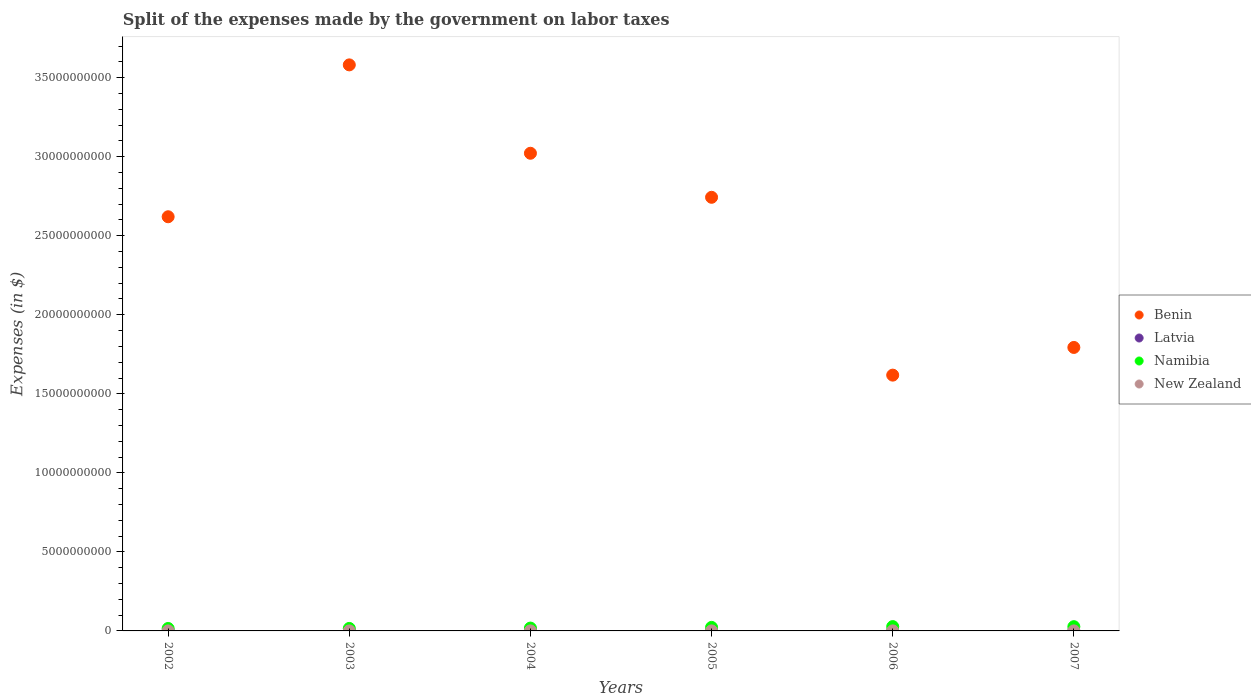How many different coloured dotlines are there?
Offer a terse response. 4. Is the number of dotlines equal to the number of legend labels?
Make the answer very short. Yes. What is the expenses made by the government on labor taxes in Latvia in 2002?
Your answer should be compact. 8.60e+06. Across all years, what is the maximum expenses made by the government on labor taxes in Namibia?
Your answer should be compact. 2.73e+08. Across all years, what is the minimum expenses made by the government on labor taxes in Benin?
Offer a terse response. 1.62e+1. In which year was the expenses made by the government on labor taxes in Namibia minimum?
Provide a succinct answer. 2002. What is the total expenses made by the government on labor taxes in Benin in the graph?
Your response must be concise. 1.54e+11. What is the difference between the expenses made by the government on labor taxes in New Zealand in 2005 and that in 2007?
Ensure brevity in your answer.  3.25e+05. What is the difference between the expenses made by the government on labor taxes in Namibia in 2002 and the expenses made by the government on labor taxes in New Zealand in 2003?
Give a very brief answer. 1.53e+08. What is the average expenses made by the government on labor taxes in Latvia per year?
Give a very brief answer. 7.77e+06. In the year 2002, what is the difference between the expenses made by the government on labor taxes in Latvia and expenses made by the government on labor taxes in Namibia?
Give a very brief answer. -1.46e+08. What is the ratio of the expenses made by the government on labor taxes in New Zealand in 2002 to that in 2007?
Provide a short and direct response. 0.66. Is the expenses made by the government on labor taxes in Latvia in 2002 less than that in 2005?
Provide a succinct answer. No. What is the difference between the highest and the second highest expenses made by the government on labor taxes in Latvia?
Make the answer very short. 2.00e+05. What is the difference between the highest and the lowest expenses made by the government on labor taxes in New Zealand?
Your answer should be very brief. 1.69e+06. Is the sum of the expenses made by the government on labor taxes in Latvia in 2002 and 2007 greater than the maximum expenses made by the government on labor taxes in Benin across all years?
Make the answer very short. No. Is it the case that in every year, the sum of the expenses made by the government on labor taxes in Namibia and expenses made by the government on labor taxes in Latvia  is greater than the sum of expenses made by the government on labor taxes in Benin and expenses made by the government on labor taxes in New Zealand?
Provide a short and direct response. No. Is the expenses made by the government on labor taxes in Latvia strictly less than the expenses made by the government on labor taxes in Namibia over the years?
Provide a succinct answer. Yes. How many years are there in the graph?
Give a very brief answer. 6. What is the difference between two consecutive major ticks on the Y-axis?
Provide a short and direct response. 5.00e+09. Are the values on the major ticks of Y-axis written in scientific E-notation?
Offer a very short reply. No. Does the graph contain any zero values?
Offer a terse response. No. Does the graph contain grids?
Your answer should be very brief. No. How are the legend labels stacked?
Provide a succinct answer. Vertical. What is the title of the graph?
Your answer should be compact. Split of the expenses made by the government on labor taxes. What is the label or title of the X-axis?
Offer a very short reply. Years. What is the label or title of the Y-axis?
Your answer should be compact. Expenses (in $). What is the Expenses (in $) in Benin in 2002?
Provide a succinct answer. 2.62e+1. What is the Expenses (in $) in Latvia in 2002?
Make the answer very short. 8.60e+06. What is the Expenses (in $) of Namibia in 2002?
Keep it short and to the point. 1.55e+08. What is the Expenses (in $) in New Zealand in 2002?
Give a very brief answer. 1.31e+06. What is the Expenses (in $) in Benin in 2003?
Offer a terse response. 3.58e+1. What is the Expenses (in $) in Latvia in 2003?
Make the answer very short. 7.80e+06. What is the Expenses (in $) in Namibia in 2003?
Your response must be concise. 1.58e+08. What is the Expenses (in $) in New Zealand in 2003?
Provide a short and direct response. 1.36e+06. What is the Expenses (in $) of Benin in 2004?
Your answer should be very brief. 3.02e+1. What is the Expenses (in $) in Latvia in 2004?
Give a very brief answer. 6.10e+06. What is the Expenses (in $) of Namibia in 2004?
Keep it short and to the point. 1.80e+08. What is the Expenses (in $) in New Zealand in 2004?
Your answer should be compact. 2.35e+06. What is the Expenses (in $) in Benin in 2005?
Provide a short and direct response. 2.74e+1. What is the Expenses (in $) in Latvia in 2005?
Offer a very short reply. 8.10e+06. What is the Expenses (in $) of Namibia in 2005?
Your answer should be compact. 2.23e+08. What is the Expenses (in $) of New Zealand in 2005?
Provide a succinct answer. 2.32e+06. What is the Expenses (in $) of Benin in 2006?
Keep it short and to the point. 1.62e+1. What is the Expenses (in $) of Latvia in 2006?
Ensure brevity in your answer.  8.40e+06. What is the Expenses (in $) of Namibia in 2006?
Give a very brief answer. 2.73e+08. What is the Expenses (in $) of New Zealand in 2006?
Your answer should be compact. 3.00e+06. What is the Expenses (in $) of Benin in 2007?
Ensure brevity in your answer.  1.79e+1. What is the Expenses (in $) in Latvia in 2007?
Offer a very short reply. 7.61e+06. What is the Expenses (in $) of Namibia in 2007?
Your response must be concise. 2.68e+08. Across all years, what is the maximum Expenses (in $) of Benin?
Your response must be concise. 3.58e+1. Across all years, what is the maximum Expenses (in $) of Latvia?
Provide a short and direct response. 8.60e+06. Across all years, what is the maximum Expenses (in $) in Namibia?
Provide a short and direct response. 2.73e+08. Across all years, what is the minimum Expenses (in $) in Benin?
Your answer should be compact. 1.62e+1. Across all years, what is the minimum Expenses (in $) of Latvia?
Keep it short and to the point. 6.10e+06. Across all years, what is the minimum Expenses (in $) in Namibia?
Keep it short and to the point. 1.55e+08. Across all years, what is the minimum Expenses (in $) in New Zealand?
Keep it short and to the point. 1.31e+06. What is the total Expenses (in $) in Benin in the graph?
Keep it short and to the point. 1.54e+11. What is the total Expenses (in $) of Latvia in the graph?
Offer a very short reply. 4.66e+07. What is the total Expenses (in $) of Namibia in the graph?
Your answer should be compact. 1.26e+09. What is the total Expenses (in $) of New Zealand in the graph?
Offer a very short reply. 1.23e+07. What is the difference between the Expenses (in $) in Benin in 2002 and that in 2003?
Provide a succinct answer. -9.61e+09. What is the difference between the Expenses (in $) of Namibia in 2002 and that in 2003?
Give a very brief answer. -3.12e+06. What is the difference between the Expenses (in $) in New Zealand in 2002 and that in 2003?
Provide a succinct answer. -4.30e+04. What is the difference between the Expenses (in $) of Benin in 2002 and that in 2004?
Provide a short and direct response. -4.02e+09. What is the difference between the Expenses (in $) of Latvia in 2002 and that in 2004?
Ensure brevity in your answer.  2.50e+06. What is the difference between the Expenses (in $) of Namibia in 2002 and that in 2004?
Offer a terse response. -2.51e+07. What is the difference between the Expenses (in $) in New Zealand in 2002 and that in 2004?
Give a very brief answer. -1.04e+06. What is the difference between the Expenses (in $) in Benin in 2002 and that in 2005?
Provide a short and direct response. -1.23e+09. What is the difference between the Expenses (in $) of Latvia in 2002 and that in 2005?
Give a very brief answer. 5.00e+05. What is the difference between the Expenses (in $) in Namibia in 2002 and that in 2005?
Ensure brevity in your answer.  -6.86e+07. What is the difference between the Expenses (in $) of New Zealand in 2002 and that in 2005?
Provide a short and direct response. -1.01e+06. What is the difference between the Expenses (in $) of Benin in 2002 and that in 2006?
Keep it short and to the point. 1.00e+1. What is the difference between the Expenses (in $) in Namibia in 2002 and that in 2006?
Give a very brief answer. -1.18e+08. What is the difference between the Expenses (in $) in New Zealand in 2002 and that in 2006?
Offer a terse response. -1.69e+06. What is the difference between the Expenses (in $) in Benin in 2002 and that in 2007?
Keep it short and to the point. 8.27e+09. What is the difference between the Expenses (in $) of Latvia in 2002 and that in 2007?
Give a very brief answer. 9.90e+05. What is the difference between the Expenses (in $) in Namibia in 2002 and that in 2007?
Offer a terse response. -1.13e+08. What is the difference between the Expenses (in $) of New Zealand in 2002 and that in 2007?
Give a very brief answer. -6.87e+05. What is the difference between the Expenses (in $) of Benin in 2003 and that in 2004?
Provide a short and direct response. 5.59e+09. What is the difference between the Expenses (in $) in Latvia in 2003 and that in 2004?
Your response must be concise. 1.70e+06. What is the difference between the Expenses (in $) in Namibia in 2003 and that in 2004?
Ensure brevity in your answer.  -2.20e+07. What is the difference between the Expenses (in $) of New Zealand in 2003 and that in 2004?
Your response must be concise. -9.93e+05. What is the difference between the Expenses (in $) of Benin in 2003 and that in 2005?
Keep it short and to the point. 8.38e+09. What is the difference between the Expenses (in $) of Latvia in 2003 and that in 2005?
Your answer should be very brief. -3.00e+05. What is the difference between the Expenses (in $) in Namibia in 2003 and that in 2005?
Provide a short and direct response. -6.55e+07. What is the difference between the Expenses (in $) of New Zealand in 2003 and that in 2005?
Your answer should be very brief. -9.69e+05. What is the difference between the Expenses (in $) in Benin in 2003 and that in 2006?
Ensure brevity in your answer.  1.96e+1. What is the difference between the Expenses (in $) in Latvia in 2003 and that in 2006?
Give a very brief answer. -6.00e+05. What is the difference between the Expenses (in $) in Namibia in 2003 and that in 2006?
Provide a short and direct response. -1.15e+08. What is the difference between the Expenses (in $) of New Zealand in 2003 and that in 2006?
Provide a short and direct response. -1.64e+06. What is the difference between the Expenses (in $) of Benin in 2003 and that in 2007?
Your answer should be very brief. 1.79e+1. What is the difference between the Expenses (in $) in Latvia in 2003 and that in 2007?
Provide a short and direct response. 1.90e+05. What is the difference between the Expenses (in $) in Namibia in 2003 and that in 2007?
Your answer should be very brief. -1.10e+08. What is the difference between the Expenses (in $) in New Zealand in 2003 and that in 2007?
Keep it short and to the point. -6.44e+05. What is the difference between the Expenses (in $) of Benin in 2004 and that in 2005?
Your answer should be very brief. 2.79e+09. What is the difference between the Expenses (in $) of Namibia in 2004 and that in 2005?
Ensure brevity in your answer.  -4.35e+07. What is the difference between the Expenses (in $) in New Zealand in 2004 and that in 2005?
Offer a terse response. 2.40e+04. What is the difference between the Expenses (in $) of Benin in 2004 and that in 2006?
Give a very brief answer. 1.40e+1. What is the difference between the Expenses (in $) in Latvia in 2004 and that in 2006?
Provide a succinct answer. -2.30e+06. What is the difference between the Expenses (in $) of Namibia in 2004 and that in 2006?
Offer a very short reply. -9.26e+07. What is the difference between the Expenses (in $) of New Zealand in 2004 and that in 2006?
Offer a terse response. -6.51e+05. What is the difference between the Expenses (in $) of Benin in 2004 and that in 2007?
Your answer should be very brief. 1.23e+1. What is the difference between the Expenses (in $) of Latvia in 2004 and that in 2007?
Your answer should be very brief. -1.51e+06. What is the difference between the Expenses (in $) of Namibia in 2004 and that in 2007?
Make the answer very short. -8.81e+07. What is the difference between the Expenses (in $) in New Zealand in 2004 and that in 2007?
Give a very brief answer. 3.49e+05. What is the difference between the Expenses (in $) of Benin in 2005 and that in 2006?
Your answer should be compact. 1.13e+1. What is the difference between the Expenses (in $) of Namibia in 2005 and that in 2006?
Your answer should be very brief. -4.91e+07. What is the difference between the Expenses (in $) in New Zealand in 2005 and that in 2006?
Make the answer very short. -6.75e+05. What is the difference between the Expenses (in $) in Benin in 2005 and that in 2007?
Provide a succinct answer. 9.50e+09. What is the difference between the Expenses (in $) in Latvia in 2005 and that in 2007?
Your response must be concise. 4.90e+05. What is the difference between the Expenses (in $) of Namibia in 2005 and that in 2007?
Your answer should be very brief. -4.45e+07. What is the difference between the Expenses (in $) of New Zealand in 2005 and that in 2007?
Your answer should be very brief. 3.25e+05. What is the difference between the Expenses (in $) of Benin in 2006 and that in 2007?
Provide a succinct answer. -1.75e+09. What is the difference between the Expenses (in $) of Latvia in 2006 and that in 2007?
Give a very brief answer. 7.90e+05. What is the difference between the Expenses (in $) of Namibia in 2006 and that in 2007?
Your answer should be very brief. 4.53e+06. What is the difference between the Expenses (in $) of Benin in 2002 and the Expenses (in $) of Latvia in 2003?
Keep it short and to the point. 2.62e+1. What is the difference between the Expenses (in $) of Benin in 2002 and the Expenses (in $) of Namibia in 2003?
Give a very brief answer. 2.60e+1. What is the difference between the Expenses (in $) of Benin in 2002 and the Expenses (in $) of New Zealand in 2003?
Your answer should be compact. 2.62e+1. What is the difference between the Expenses (in $) of Latvia in 2002 and the Expenses (in $) of Namibia in 2003?
Offer a terse response. -1.49e+08. What is the difference between the Expenses (in $) of Latvia in 2002 and the Expenses (in $) of New Zealand in 2003?
Your response must be concise. 7.24e+06. What is the difference between the Expenses (in $) of Namibia in 2002 and the Expenses (in $) of New Zealand in 2003?
Keep it short and to the point. 1.53e+08. What is the difference between the Expenses (in $) in Benin in 2002 and the Expenses (in $) in Latvia in 2004?
Ensure brevity in your answer.  2.62e+1. What is the difference between the Expenses (in $) of Benin in 2002 and the Expenses (in $) of Namibia in 2004?
Your response must be concise. 2.60e+1. What is the difference between the Expenses (in $) in Benin in 2002 and the Expenses (in $) in New Zealand in 2004?
Offer a very short reply. 2.62e+1. What is the difference between the Expenses (in $) in Latvia in 2002 and the Expenses (in $) in Namibia in 2004?
Make the answer very short. -1.71e+08. What is the difference between the Expenses (in $) of Latvia in 2002 and the Expenses (in $) of New Zealand in 2004?
Give a very brief answer. 6.25e+06. What is the difference between the Expenses (in $) in Namibia in 2002 and the Expenses (in $) in New Zealand in 2004?
Make the answer very short. 1.52e+08. What is the difference between the Expenses (in $) in Benin in 2002 and the Expenses (in $) in Latvia in 2005?
Make the answer very short. 2.62e+1. What is the difference between the Expenses (in $) in Benin in 2002 and the Expenses (in $) in Namibia in 2005?
Keep it short and to the point. 2.60e+1. What is the difference between the Expenses (in $) of Benin in 2002 and the Expenses (in $) of New Zealand in 2005?
Keep it short and to the point. 2.62e+1. What is the difference between the Expenses (in $) of Latvia in 2002 and the Expenses (in $) of Namibia in 2005?
Your response must be concise. -2.15e+08. What is the difference between the Expenses (in $) of Latvia in 2002 and the Expenses (in $) of New Zealand in 2005?
Your response must be concise. 6.28e+06. What is the difference between the Expenses (in $) in Namibia in 2002 and the Expenses (in $) in New Zealand in 2005?
Your response must be concise. 1.53e+08. What is the difference between the Expenses (in $) in Benin in 2002 and the Expenses (in $) in Latvia in 2006?
Your answer should be very brief. 2.62e+1. What is the difference between the Expenses (in $) in Benin in 2002 and the Expenses (in $) in Namibia in 2006?
Keep it short and to the point. 2.59e+1. What is the difference between the Expenses (in $) in Benin in 2002 and the Expenses (in $) in New Zealand in 2006?
Offer a terse response. 2.62e+1. What is the difference between the Expenses (in $) in Latvia in 2002 and the Expenses (in $) in Namibia in 2006?
Give a very brief answer. -2.64e+08. What is the difference between the Expenses (in $) of Latvia in 2002 and the Expenses (in $) of New Zealand in 2006?
Your response must be concise. 5.60e+06. What is the difference between the Expenses (in $) in Namibia in 2002 and the Expenses (in $) in New Zealand in 2006?
Provide a short and direct response. 1.52e+08. What is the difference between the Expenses (in $) of Benin in 2002 and the Expenses (in $) of Latvia in 2007?
Your answer should be very brief. 2.62e+1. What is the difference between the Expenses (in $) of Benin in 2002 and the Expenses (in $) of Namibia in 2007?
Offer a very short reply. 2.59e+1. What is the difference between the Expenses (in $) of Benin in 2002 and the Expenses (in $) of New Zealand in 2007?
Ensure brevity in your answer.  2.62e+1. What is the difference between the Expenses (in $) in Latvia in 2002 and the Expenses (in $) in Namibia in 2007?
Provide a succinct answer. -2.59e+08. What is the difference between the Expenses (in $) in Latvia in 2002 and the Expenses (in $) in New Zealand in 2007?
Your answer should be compact. 6.60e+06. What is the difference between the Expenses (in $) of Namibia in 2002 and the Expenses (in $) of New Zealand in 2007?
Your response must be concise. 1.53e+08. What is the difference between the Expenses (in $) in Benin in 2003 and the Expenses (in $) in Latvia in 2004?
Your answer should be very brief. 3.58e+1. What is the difference between the Expenses (in $) of Benin in 2003 and the Expenses (in $) of Namibia in 2004?
Make the answer very short. 3.56e+1. What is the difference between the Expenses (in $) in Benin in 2003 and the Expenses (in $) in New Zealand in 2004?
Your response must be concise. 3.58e+1. What is the difference between the Expenses (in $) of Latvia in 2003 and the Expenses (in $) of Namibia in 2004?
Provide a succinct answer. -1.72e+08. What is the difference between the Expenses (in $) of Latvia in 2003 and the Expenses (in $) of New Zealand in 2004?
Make the answer very short. 5.45e+06. What is the difference between the Expenses (in $) in Namibia in 2003 and the Expenses (in $) in New Zealand in 2004?
Provide a short and direct response. 1.56e+08. What is the difference between the Expenses (in $) in Benin in 2003 and the Expenses (in $) in Latvia in 2005?
Make the answer very short. 3.58e+1. What is the difference between the Expenses (in $) of Benin in 2003 and the Expenses (in $) of Namibia in 2005?
Provide a succinct answer. 3.56e+1. What is the difference between the Expenses (in $) of Benin in 2003 and the Expenses (in $) of New Zealand in 2005?
Your answer should be very brief. 3.58e+1. What is the difference between the Expenses (in $) in Latvia in 2003 and the Expenses (in $) in Namibia in 2005?
Offer a terse response. -2.16e+08. What is the difference between the Expenses (in $) in Latvia in 2003 and the Expenses (in $) in New Zealand in 2005?
Give a very brief answer. 5.48e+06. What is the difference between the Expenses (in $) of Namibia in 2003 and the Expenses (in $) of New Zealand in 2005?
Keep it short and to the point. 1.56e+08. What is the difference between the Expenses (in $) in Benin in 2003 and the Expenses (in $) in Latvia in 2006?
Ensure brevity in your answer.  3.58e+1. What is the difference between the Expenses (in $) of Benin in 2003 and the Expenses (in $) of Namibia in 2006?
Offer a very short reply. 3.55e+1. What is the difference between the Expenses (in $) in Benin in 2003 and the Expenses (in $) in New Zealand in 2006?
Your answer should be compact. 3.58e+1. What is the difference between the Expenses (in $) of Latvia in 2003 and the Expenses (in $) of Namibia in 2006?
Your answer should be very brief. -2.65e+08. What is the difference between the Expenses (in $) in Latvia in 2003 and the Expenses (in $) in New Zealand in 2006?
Keep it short and to the point. 4.80e+06. What is the difference between the Expenses (in $) in Namibia in 2003 and the Expenses (in $) in New Zealand in 2006?
Offer a terse response. 1.55e+08. What is the difference between the Expenses (in $) of Benin in 2003 and the Expenses (in $) of Latvia in 2007?
Provide a succinct answer. 3.58e+1. What is the difference between the Expenses (in $) in Benin in 2003 and the Expenses (in $) in Namibia in 2007?
Keep it short and to the point. 3.55e+1. What is the difference between the Expenses (in $) in Benin in 2003 and the Expenses (in $) in New Zealand in 2007?
Make the answer very short. 3.58e+1. What is the difference between the Expenses (in $) in Latvia in 2003 and the Expenses (in $) in Namibia in 2007?
Your response must be concise. -2.60e+08. What is the difference between the Expenses (in $) in Latvia in 2003 and the Expenses (in $) in New Zealand in 2007?
Offer a very short reply. 5.80e+06. What is the difference between the Expenses (in $) of Namibia in 2003 and the Expenses (in $) of New Zealand in 2007?
Your response must be concise. 1.56e+08. What is the difference between the Expenses (in $) in Benin in 2004 and the Expenses (in $) in Latvia in 2005?
Make the answer very short. 3.02e+1. What is the difference between the Expenses (in $) of Benin in 2004 and the Expenses (in $) of Namibia in 2005?
Your answer should be very brief. 3.00e+1. What is the difference between the Expenses (in $) in Benin in 2004 and the Expenses (in $) in New Zealand in 2005?
Your answer should be very brief. 3.02e+1. What is the difference between the Expenses (in $) of Latvia in 2004 and the Expenses (in $) of Namibia in 2005?
Make the answer very short. -2.17e+08. What is the difference between the Expenses (in $) of Latvia in 2004 and the Expenses (in $) of New Zealand in 2005?
Your answer should be compact. 3.78e+06. What is the difference between the Expenses (in $) in Namibia in 2004 and the Expenses (in $) in New Zealand in 2005?
Provide a succinct answer. 1.78e+08. What is the difference between the Expenses (in $) of Benin in 2004 and the Expenses (in $) of Latvia in 2006?
Your answer should be compact. 3.02e+1. What is the difference between the Expenses (in $) of Benin in 2004 and the Expenses (in $) of Namibia in 2006?
Ensure brevity in your answer.  2.99e+1. What is the difference between the Expenses (in $) in Benin in 2004 and the Expenses (in $) in New Zealand in 2006?
Keep it short and to the point. 3.02e+1. What is the difference between the Expenses (in $) in Latvia in 2004 and the Expenses (in $) in Namibia in 2006?
Keep it short and to the point. -2.66e+08. What is the difference between the Expenses (in $) in Latvia in 2004 and the Expenses (in $) in New Zealand in 2006?
Keep it short and to the point. 3.10e+06. What is the difference between the Expenses (in $) in Namibia in 2004 and the Expenses (in $) in New Zealand in 2006?
Your response must be concise. 1.77e+08. What is the difference between the Expenses (in $) of Benin in 2004 and the Expenses (in $) of Latvia in 2007?
Your answer should be very brief. 3.02e+1. What is the difference between the Expenses (in $) in Benin in 2004 and the Expenses (in $) in Namibia in 2007?
Keep it short and to the point. 3.00e+1. What is the difference between the Expenses (in $) in Benin in 2004 and the Expenses (in $) in New Zealand in 2007?
Ensure brevity in your answer.  3.02e+1. What is the difference between the Expenses (in $) of Latvia in 2004 and the Expenses (in $) of Namibia in 2007?
Offer a terse response. -2.62e+08. What is the difference between the Expenses (in $) in Latvia in 2004 and the Expenses (in $) in New Zealand in 2007?
Provide a succinct answer. 4.10e+06. What is the difference between the Expenses (in $) of Namibia in 2004 and the Expenses (in $) of New Zealand in 2007?
Ensure brevity in your answer.  1.78e+08. What is the difference between the Expenses (in $) in Benin in 2005 and the Expenses (in $) in Latvia in 2006?
Keep it short and to the point. 2.74e+1. What is the difference between the Expenses (in $) in Benin in 2005 and the Expenses (in $) in Namibia in 2006?
Offer a very short reply. 2.72e+1. What is the difference between the Expenses (in $) of Benin in 2005 and the Expenses (in $) of New Zealand in 2006?
Offer a very short reply. 2.74e+1. What is the difference between the Expenses (in $) in Latvia in 2005 and the Expenses (in $) in Namibia in 2006?
Offer a terse response. -2.64e+08. What is the difference between the Expenses (in $) in Latvia in 2005 and the Expenses (in $) in New Zealand in 2006?
Give a very brief answer. 5.10e+06. What is the difference between the Expenses (in $) of Namibia in 2005 and the Expenses (in $) of New Zealand in 2006?
Provide a short and direct response. 2.20e+08. What is the difference between the Expenses (in $) in Benin in 2005 and the Expenses (in $) in Latvia in 2007?
Offer a terse response. 2.74e+1. What is the difference between the Expenses (in $) of Benin in 2005 and the Expenses (in $) of Namibia in 2007?
Provide a short and direct response. 2.72e+1. What is the difference between the Expenses (in $) in Benin in 2005 and the Expenses (in $) in New Zealand in 2007?
Offer a terse response. 2.74e+1. What is the difference between the Expenses (in $) of Latvia in 2005 and the Expenses (in $) of Namibia in 2007?
Offer a terse response. -2.60e+08. What is the difference between the Expenses (in $) in Latvia in 2005 and the Expenses (in $) in New Zealand in 2007?
Your answer should be compact. 6.10e+06. What is the difference between the Expenses (in $) of Namibia in 2005 and the Expenses (in $) of New Zealand in 2007?
Your answer should be very brief. 2.21e+08. What is the difference between the Expenses (in $) of Benin in 2006 and the Expenses (in $) of Latvia in 2007?
Ensure brevity in your answer.  1.62e+1. What is the difference between the Expenses (in $) in Benin in 2006 and the Expenses (in $) in Namibia in 2007?
Your response must be concise. 1.59e+1. What is the difference between the Expenses (in $) in Benin in 2006 and the Expenses (in $) in New Zealand in 2007?
Your answer should be very brief. 1.62e+1. What is the difference between the Expenses (in $) of Latvia in 2006 and the Expenses (in $) of Namibia in 2007?
Offer a very short reply. -2.60e+08. What is the difference between the Expenses (in $) in Latvia in 2006 and the Expenses (in $) in New Zealand in 2007?
Provide a succinct answer. 6.40e+06. What is the difference between the Expenses (in $) of Namibia in 2006 and the Expenses (in $) of New Zealand in 2007?
Your response must be concise. 2.71e+08. What is the average Expenses (in $) in Benin per year?
Your answer should be very brief. 2.56e+1. What is the average Expenses (in $) in Latvia per year?
Offer a terse response. 7.77e+06. What is the average Expenses (in $) in Namibia per year?
Provide a short and direct response. 2.09e+08. What is the average Expenses (in $) in New Zealand per year?
Your answer should be very brief. 2.06e+06. In the year 2002, what is the difference between the Expenses (in $) of Benin and Expenses (in $) of Latvia?
Your answer should be very brief. 2.62e+1. In the year 2002, what is the difference between the Expenses (in $) in Benin and Expenses (in $) in Namibia?
Your answer should be compact. 2.60e+1. In the year 2002, what is the difference between the Expenses (in $) of Benin and Expenses (in $) of New Zealand?
Give a very brief answer. 2.62e+1. In the year 2002, what is the difference between the Expenses (in $) in Latvia and Expenses (in $) in Namibia?
Your answer should be compact. -1.46e+08. In the year 2002, what is the difference between the Expenses (in $) of Latvia and Expenses (in $) of New Zealand?
Ensure brevity in your answer.  7.29e+06. In the year 2002, what is the difference between the Expenses (in $) of Namibia and Expenses (in $) of New Zealand?
Ensure brevity in your answer.  1.54e+08. In the year 2003, what is the difference between the Expenses (in $) of Benin and Expenses (in $) of Latvia?
Ensure brevity in your answer.  3.58e+1. In the year 2003, what is the difference between the Expenses (in $) in Benin and Expenses (in $) in Namibia?
Provide a short and direct response. 3.57e+1. In the year 2003, what is the difference between the Expenses (in $) in Benin and Expenses (in $) in New Zealand?
Ensure brevity in your answer.  3.58e+1. In the year 2003, what is the difference between the Expenses (in $) in Latvia and Expenses (in $) in Namibia?
Ensure brevity in your answer.  -1.50e+08. In the year 2003, what is the difference between the Expenses (in $) in Latvia and Expenses (in $) in New Zealand?
Offer a very short reply. 6.44e+06. In the year 2003, what is the difference between the Expenses (in $) of Namibia and Expenses (in $) of New Zealand?
Your response must be concise. 1.57e+08. In the year 2004, what is the difference between the Expenses (in $) of Benin and Expenses (in $) of Latvia?
Your answer should be very brief. 3.02e+1. In the year 2004, what is the difference between the Expenses (in $) of Benin and Expenses (in $) of Namibia?
Give a very brief answer. 3.00e+1. In the year 2004, what is the difference between the Expenses (in $) in Benin and Expenses (in $) in New Zealand?
Offer a very short reply. 3.02e+1. In the year 2004, what is the difference between the Expenses (in $) of Latvia and Expenses (in $) of Namibia?
Offer a terse response. -1.74e+08. In the year 2004, what is the difference between the Expenses (in $) of Latvia and Expenses (in $) of New Zealand?
Your response must be concise. 3.75e+06. In the year 2004, what is the difference between the Expenses (in $) of Namibia and Expenses (in $) of New Zealand?
Keep it short and to the point. 1.78e+08. In the year 2005, what is the difference between the Expenses (in $) in Benin and Expenses (in $) in Latvia?
Your answer should be compact. 2.74e+1. In the year 2005, what is the difference between the Expenses (in $) of Benin and Expenses (in $) of Namibia?
Offer a very short reply. 2.72e+1. In the year 2005, what is the difference between the Expenses (in $) of Benin and Expenses (in $) of New Zealand?
Give a very brief answer. 2.74e+1. In the year 2005, what is the difference between the Expenses (in $) in Latvia and Expenses (in $) in Namibia?
Provide a short and direct response. -2.15e+08. In the year 2005, what is the difference between the Expenses (in $) of Latvia and Expenses (in $) of New Zealand?
Keep it short and to the point. 5.78e+06. In the year 2005, what is the difference between the Expenses (in $) in Namibia and Expenses (in $) in New Zealand?
Provide a succinct answer. 2.21e+08. In the year 2006, what is the difference between the Expenses (in $) of Benin and Expenses (in $) of Latvia?
Your response must be concise. 1.62e+1. In the year 2006, what is the difference between the Expenses (in $) of Benin and Expenses (in $) of Namibia?
Make the answer very short. 1.59e+1. In the year 2006, what is the difference between the Expenses (in $) in Benin and Expenses (in $) in New Zealand?
Provide a succinct answer. 1.62e+1. In the year 2006, what is the difference between the Expenses (in $) of Latvia and Expenses (in $) of Namibia?
Give a very brief answer. -2.64e+08. In the year 2006, what is the difference between the Expenses (in $) in Latvia and Expenses (in $) in New Zealand?
Your response must be concise. 5.40e+06. In the year 2006, what is the difference between the Expenses (in $) in Namibia and Expenses (in $) in New Zealand?
Offer a very short reply. 2.70e+08. In the year 2007, what is the difference between the Expenses (in $) in Benin and Expenses (in $) in Latvia?
Offer a terse response. 1.79e+1. In the year 2007, what is the difference between the Expenses (in $) of Benin and Expenses (in $) of Namibia?
Keep it short and to the point. 1.77e+1. In the year 2007, what is the difference between the Expenses (in $) of Benin and Expenses (in $) of New Zealand?
Give a very brief answer. 1.79e+1. In the year 2007, what is the difference between the Expenses (in $) of Latvia and Expenses (in $) of Namibia?
Your answer should be very brief. -2.60e+08. In the year 2007, what is the difference between the Expenses (in $) of Latvia and Expenses (in $) of New Zealand?
Provide a succinct answer. 5.61e+06. In the year 2007, what is the difference between the Expenses (in $) of Namibia and Expenses (in $) of New Zealand?
Ensure brevity in your answer.  2.66e+08. What is the ratio of the Expenses (in $) of Benin in 2002 to that in 2003?
Offer a terse response. 0.73. What is the ratio of the Expenses (in $) in Latvia in 2002 to that in 2003?
Your answer should be very brief. 1.1. What is the ratio of the Expenses (in $) of Namibia in 2002 to that in 2003?
Your answer should be compact. 0.98. What is the ratio of the Expenses (in $) of New Zealand in 2002 to that in 2003?
Your answer should be compact. 0.97. What is the ratio of the Expenses (in $) of Benin in 2002 to that in 2004?
Give a very brief answer. 0.87. What is the ratio of the Expenses (in $) in Latvia in 2002 to that in 2004?
Your answer should be compact. 1.41. What is the ratio of the Expenses (in $) of Namibia in 2002 to that in 2004?
Ensure brevity in your answer.  0.86. What is the ratio of the Expenses (in $) in New Zealand in 2002 to that in 2004?
Ensure brevity in your answer.  0.56. What is the ratio of the Expenses (in $) in Benin in 2002 to that in 2005?
Your answer should be compact. 0.96. What is the ratio of the Expenses (in $) of Latvia in 2002 to that in 2005?
Offer a very short reply. 1.06. What is the ratio of the Expenses (in $) of Namibia in 2002 to that in 2005?
Give a very brief answer. 0.69. What is the ratio of the Expenses (in $) in New Zealand in 2002 to that in 2005?
Offer a very short reply. 0.56. What is the ratio of the Expenses (in $) in Benin in 2002 to that in 2006?
Ensure brevity in your answer.  1.62. What is the ratio of the Expenses (in $) in Latvia in 2002 to that in 2006?
Offer a terse response. 1.02. What is the ratio of the Expenses (in $) in Namibia in 2002 to that in 2006?
Give a very brief answer. 0.57. What is the ratio of the Expenses (in $) in New Zealand in 2002 to that in 2006?
Provide a short and direct response. 0.44. What is the ratio of the Expenses (in $) in Benin in 2002 to that in 2007?
Offer a very short reply. 1.46. What is the ratio of the Expenses (in $) in Latvia in 2002 to that in 2007?
Your answer should be compact. 1.13. What is the ratio of the Expenses (in $) of Namibia in 2002 to that in 2007?
Keep it short and to the point. 0.58. What is the ratio of the Expenses (in $) of New Zealand in 2002 to that in 2007?
Ensure brevity in your answer.  0.66. What is the ratio of the Expenses (in $) of Benin in 2003 to that in 2004?
Keep it short and to the point. 1.19. What is the ratio of the Expenses (in $) in Latvia in 2003 to that in 2004?
Ensure brevity in your answer.  1.28. What is the ratio of the Expenses (in $) of Namibia in 2003 to that in 2004?
Offer a very short reply. 0.88. What is the ratio of the Expenses (in $) of New Zealand in 2003 to that in 2004?
Your answer should be compact. 0.58. What is the ratio of the Expenses (in $) of Benin in 2003 to that in 2005?
Offer a terse response. 1.31. What is the ratio of the Expenses (in $) of Latvia in 2003 to that in 2005?
Ensure brevity in your answer.  0.96. What is the ratio of the Expenses (in $) of Namibia in 2003 to that in 2005?
Keep it short and to the point. 0.71. What is the ratio of the Expenses (in $) in New Zealand in 2003 to that in 2005?
Your answer should be very brief. 0.58. What is the ratio of the Expenses (in $) of Benin in 2003 to that in 2006?
Make the answer very short. 2.21. What is the ratio of the Expenses (in $) in Namibia in 2003 to that in 2006?
Your answer should be very brief. 0.58. What is the ratio of the Expenses (in $) of New Zealand in 2003 to that in 2006?
Ensure brevity in your answer.  0.45. What is the ratio of the Expenses (in $) of Benin in 2003 to that in 2007?
Make the answer very short. 2. What is the ratio of the Expenses (in $) of Latvia in 2003 to that in 2007?
Ensure brevity in your answer.  1.02. What is the ratio of the Expenses (in $) of Namibia in 2003 to that in 2007?
Your response must be concise. 0.59. What is the ratio of the Expenses (in $) of New Zealand in 2003 to that in 2007?
Offer a very short reply. 0.68. What is the ratio of the Expenses (in $) of Benin in 2004 to that in 2005?
Offer a very short reply. 1.1. What is the ratio of the Expenses (in $) of Latvia in 2004 to that in 2005?
Your answer should be compact. 0.75. What is the ratio of the Expenses (in $) in Namibia in 2004 to that in 2005?
Give a very brief answer. 0.81. What is the ratio of the Expenses (in $) of New Zealand in 2004 to that in 2005?
Provide a short and direct response. 1.01. What is the ratio of the Expenses (in $) in Benin in 2004 to that in 2006?
Give a very brief answer. 1.87. What is the ratio of the Expenses (in $) of Latvia in 2004 to that in 2006?
Make the answer very short. 0.73. What is the ratio of the Expenses (in $) of Namibia in 2004 to that in 2006?
Give a very brief answer. 0.66. What is the ratio of the Expenses (in $) of New Zealand in 2004 to that in 2006?
Your response must be concise. 0.78. What is the ratio of the Expenses (in $) of Benin in 2004 to that in 2007?
Provide a short and direct response. 1.69. What is the ratio of the Expenses (in $) in Latvia in 2004 to that in 2007?
Your answer should be very brief. 0.8. What is the ratio of the Expenses (in $) of Namibia in 2004 to that in 2007?
Your response must be concise. 0.67. What is the ratio of the Expenses (in $) in New Zealand in 2004 to that in 2007?
Provide a succinct answer. 1.17. What is the ratio of the Expenses (in $) in Benin in 2005 to that in 2006?
Provide a succinct answer. 1.7. What is the ratio of the Expenses (in $) of Namibia in 2005 to that in 2006?
Ensure brevity in your answer.  0.82. What is the ratio of the Expenses (in $) of New Zealand in 2005 to that in 2006?
Keep it short and to the point. 0.78. What is the ratio of the Expenses (in $) in Benin in 2005 to that in 2007?
Your response must be concise. 1.53. What is the ratio of the Expenses (in $) in Latvia in 2005 to that in 2007?
Provide a short and direct response. 1.06. What is the ratio of the Expenses (in $) in Namibia in 2005 to that in 2007?
Keep it short and to the point. 0.83. What is the ratio of the Expenses (in $) of New Zealand in 2005 to that in 2007?
Ensure brevity in your answer.  1.16. What is the ratio of the Expenses (in $) in Benin in 2006 to that in 2007?
Your answer should be compact. 0.9. What is the ratio of the Expenses (in $) in Latvia in 2006 to that in 2007?
Give a very brief answer. 1.1. What is the ratio of the Expenses (in $) of Namibia in 2006 to that in 2007?
Provide a short and direct response. 1.02. What is the difference between the highest and the second highest Expenses (in $) of Benin?
Provide a short and direct response. 5.59e+09. What is the difference between the highest and the second highest Expenses (in $) of Namibia?
Keep it short and to the point. 4.53e+06. What is the difference between the highest and the second highest Expenses (in $) in New Zealand?
Keep it short and to the point. 6.51e+05. What is the difference between the highest and the lowest Expenses (in $) in Benin?
Provide a succinct answer. 1.96e+1. What is the difference between the highest and the lowest Expenses (in $) in Latvia?
Provide a short and direct response. 2.50e+06. What is the difference between the highest and the lowest Expenses (in $) of Namibia?
Provide a succinct answer. 1.18e+08. What is the difference between the highest and the lowest Expenses (in $) of New Zealand?
Offer a very short reply. 1.69e+06. 